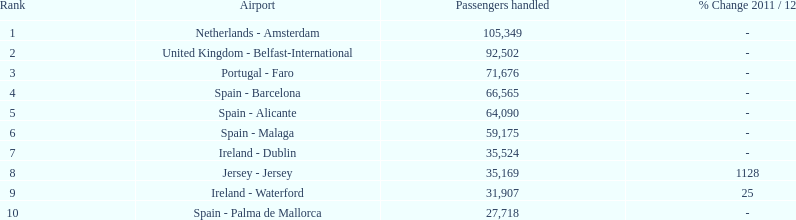What is the number of passengers traveling to or arriving from spain? 217,548. 